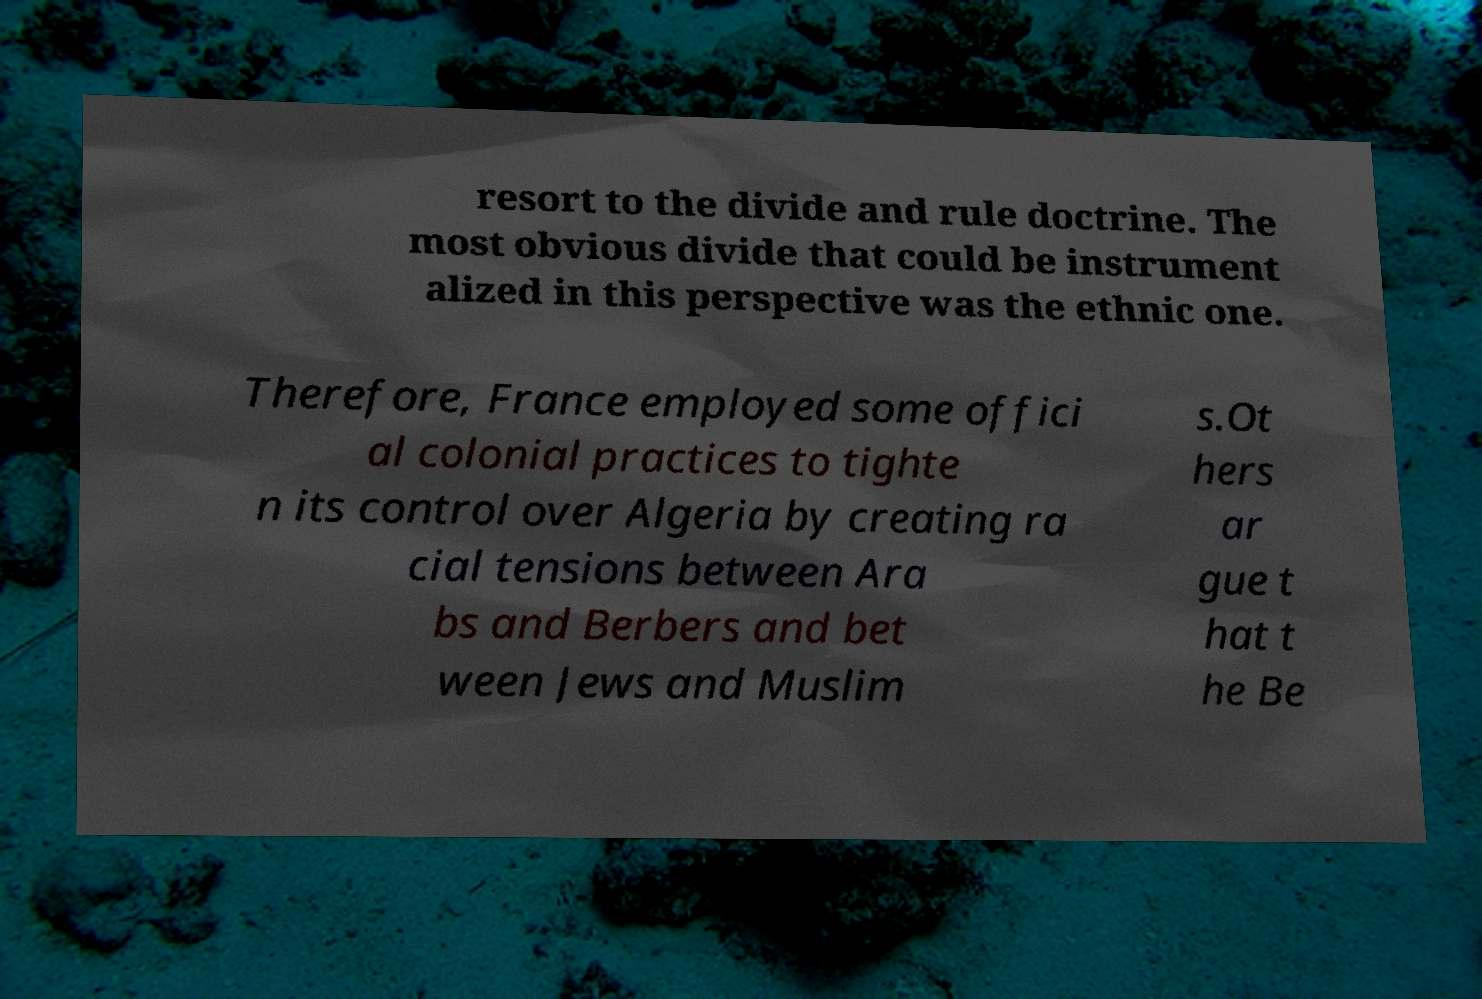Can you read and provide the text displayed in the image?This photo seems to have some interesting text. Can you extract and type it out for me? resort to the divide and rule doctrine. The most obvious divide that could be instrument alized in this perspective was the ethnic one. Therefore, France employed some offici al colonial practices to tighte n its control over Algeria by creating ra cial tensions between Ara bs and Berbers and bet ween Jews and Muslim s.Ot hers ar gue t hat t he Be 